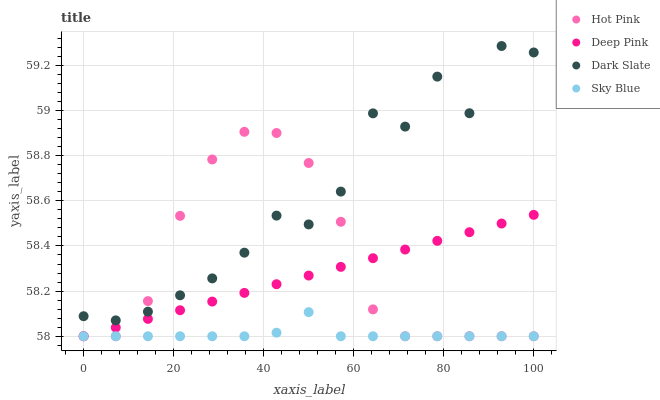Does Sky Blue have the minimum area under the curve?
Answer yes or no. Yes. Does Dark Slate have the maximum area under the curve?
Answer yes or no. Yes. Does Hot Pink have the minimum area under the curve?
Answer yes or no. No. Does Hot Pink have the maximum area under the curve?
Answer yes or no. No. Is Deep Pink the smoothest?
Answer yes or no. Yes. Is Dark Slate the roughest?
Answer yes or no. Yes. Is Hot Pink the smoothest?
Answer yes or no. No. Is Hot Pink the roughest?
Answer yes or no. No. Does Hot Pink have the lowest value?
Answer yes or no. Yes. Does Dark Slate have the highest value?
Answer yes or no. Yes. Does Hot Pink have the highest value?
Answer yes or no. No. Is Deep Pink less than Dark Slate?
Answer yes or no. Yes. Is Dark Slate greater than Deep Pink?
Answer yes or no. Yes. Does Deep Pink intersect Hot Pink?
Answer yes or no. Yes. Is Deep Pink less than Hot Pink?
Answer yes or no. No. Is Deep Pink greater than Hot Pink?
Answer yes or no. No. Does Deep Pink intersect Dark Slate?
Answer yes or no. No. 